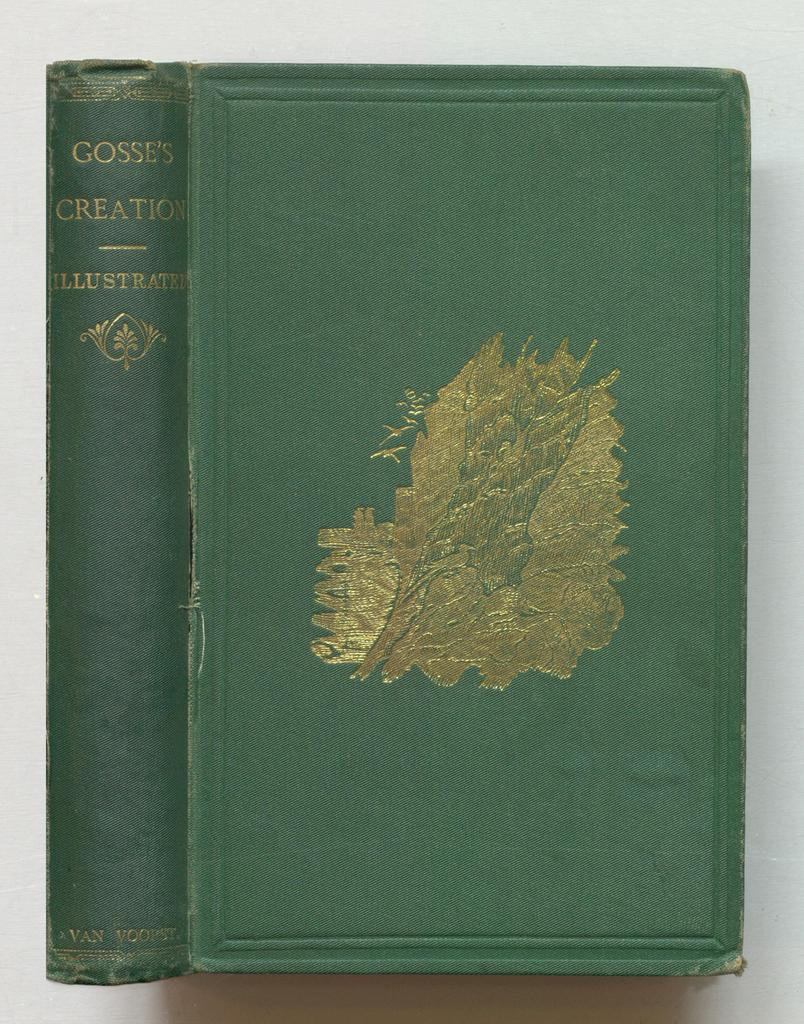<image>
Relay a brief, clear account of the picture shown. A green book says Gosse's Creation Illustrated on the binding. 